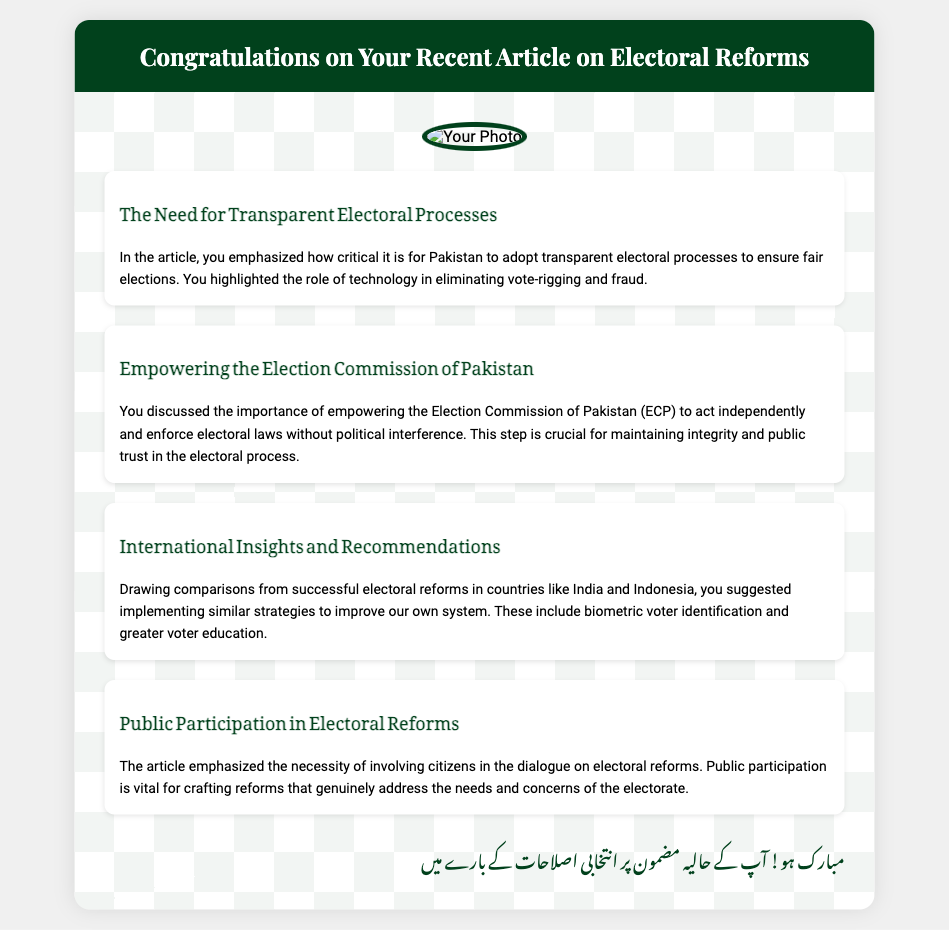What is the title of the card? The title of the card is prominently displayed in the header section.
Answer: Congratulations on Your Recent Article on Electoral Reforms Who is the main subject of the congratulatory message? The main subject is indicated by the presence of their photo featured on the card.
Answer: You What is one key topic discussed in the article? The excerpts summarize important topics addressed in the article, one of which is directly mentioned.
Answer: Transparent electoral processes What does the article suggest to eliminate vote-rigging? The importance of technology in electoral processes is emphasized in the article excerpts.
Answer: Technology According to the card, which commission should be empowered? The document mentions the specific commission whose empowerment is crucial for electoral integrity.
Answer: Election Commission of Pakistan Which countries are compared in the article? The article draws comparisons about electoral reforms with specific countries mentioned in the excerpts.
Answer: India and Indonesia What is the Urdu phrase highlighted in the card? The Urdu text is a congratulatory message that appears at the end of the card.
Answer: مبارک ہو! What is the overall purpose of this card? The card serves a specific purpose related to the accomplishment recognized in its content.
Answer: Congratulate on the article What style of font is used for the Urdu text? The document specifies the font style selected for the Urdu text to ensure cultural representation.
Answer: Noto Nastaliq Urdu What type of document is this? The structure and content of the card classify it distinctly within a certain type of communication format.
Answer: Greeting card 